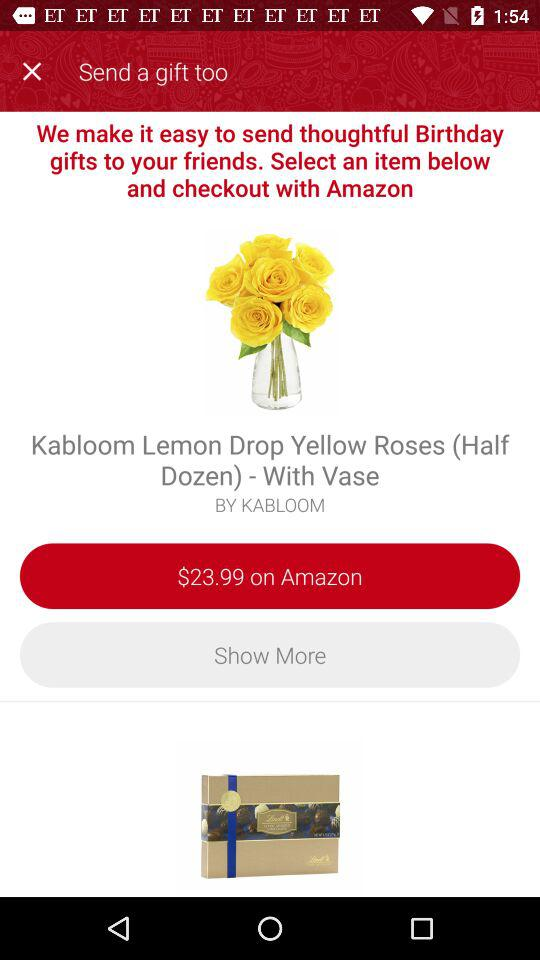What is the name of the product? The product name is "Kabloom Lemon Drop Yellow Roses (Half Dozen) - With Vase". 